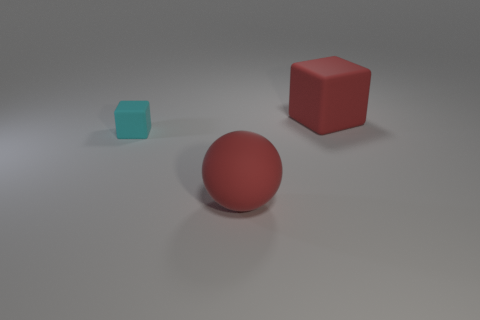Subtract all red blocks. How many blocks are left? 1 Subtract all blocks. How many objects are left? 1 Subtract 1 spheres. How many spheres are left? 0 Subtract all cubes. Subtract all big blue rubber cylinders. How many objects are left? 1 Add 2 big red objects. How many big red objects are left? 4 Add 3 large matte spheres. How many large matte spheres exist? 4 Add 1 gray things. How many objects exist? 4 Subtract 0 brown spheres. How many objects are left? 3 Subtract all gray cubes. Subtract all yellow cylinders. How many cubes are left? 2 Subtract all gray cylinders. How many red cubes are left? 1 